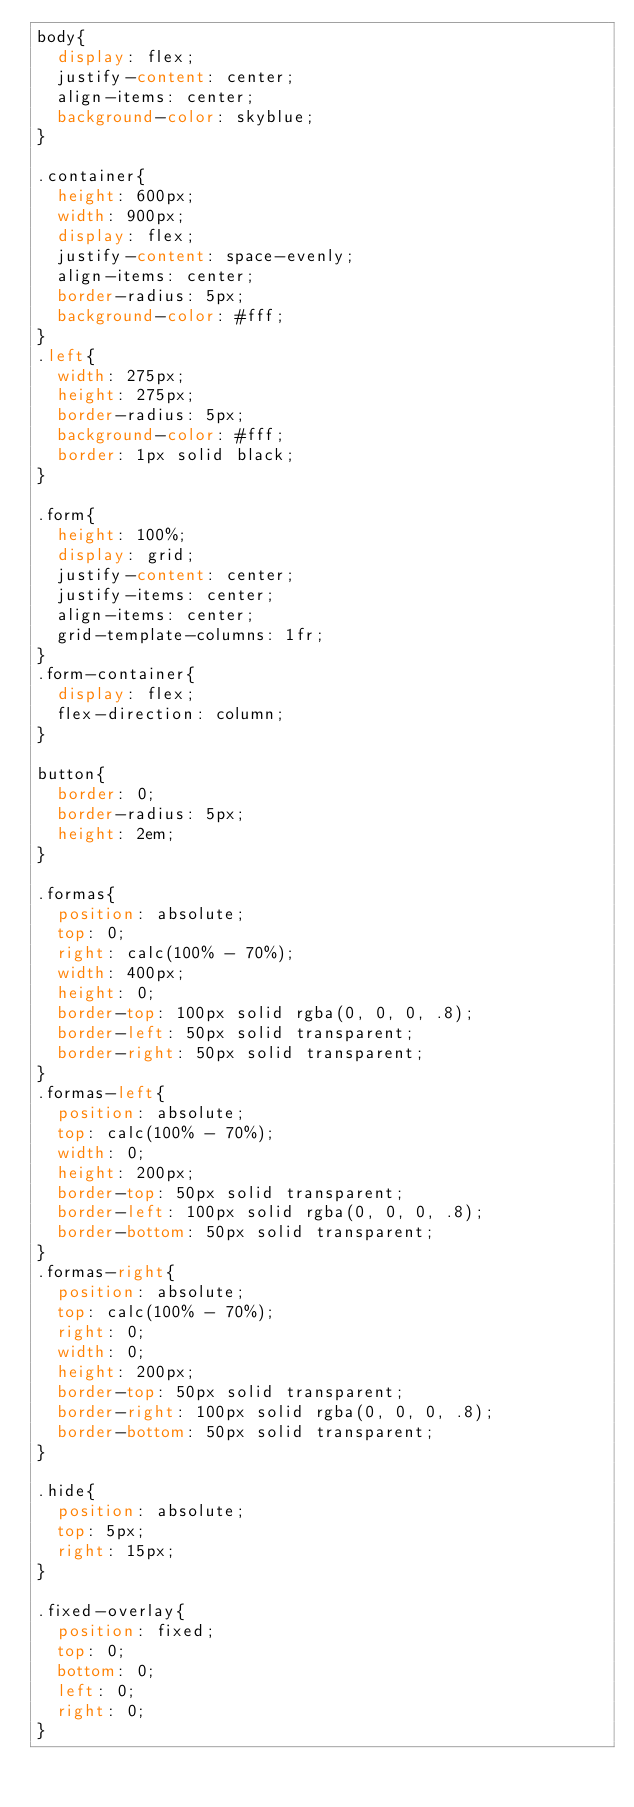Convert code to text. <code><loc_0><loc_0><loc_500><loc_500><_CSS_>body{
  display: flex;
  justify-content: center;
  align-items: center;
  background-color: skyblue;
}

.container{
  height: 600px;
  width: 900px;
  display: flex;
  justify-content: space-evenly;
  align-items: center;
  border-radius: 5px;
  background-color: #fff;
}
.left{
  width: 275px;
  height: 275px;
  border-radius: 5px;
  background-color: #fff;
  border: 1px solid black;
}

.form{
  height: 100%;
  display: grid;
  justify-content: center;
  justify-items: center;
  align-items: center;
  grid-template-columns: 1fr;
}
.form-container{
  display: flex;
  flex-direction: column;
}

button{
  border: 0;
  border-radius: 5px;
  height: 2em;
}

.formas{
  position: absolute;
  top: 0;
  right: calc(100% - 70%);
  width: 400px;
  height: 0;
  border-top: 100px solid rgba(0, 0, 0, .8);
  border-left: 50px solid transparent;
  border-right: 50px solid transparent;
}
.formas-left{
  position: absolute;
  top: calc(100% - 70%);
  width: 0;
  height: 200px;
  border-top: 50px solid transparent;
  border-left: 100px solid rgba(0, 0, 0, .8);
  border-bottom: 50px solid transparent;
}
.formas-right{
  position: absolute;
  top: calc(100% - 70%);
  right: 0;
  width: 0;
  height: 200px;
  border-top: 50px solid transparent;
  border-right: 100px solid rgba(0, 0, 0, .8);
  border-bottom: 50px solid transparent;
}

.hide{
  position: absolute;
  top: 5px;
  right: 15px;
}

.fixed-overlay{
  position: fixed;
  top: 0;
  bottom: 0;
  left: 0;
  right: 0;
}</code> 